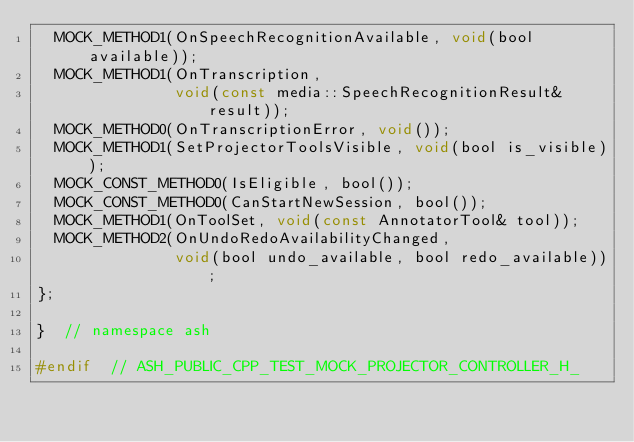Convert code to text. <code><loc_0><loc_0><loc_500><loc_500><_C_>  MOCK_METHOD1(OnSpeechRecognitionAvailable, void(bool available));
  MOCK_METHOD1(OnTranscription,
               void(const media::SpeechRecognitionResult& result));
  MOCK_METHOD0(OnTranscriptionError, void());
  MOCK_METHOD1(SetProjectorToolsVisible, void(bool is_visible));
  MOCK_CONST_METHOD0(IsEligible, bool());
  MOCK_CONST_METHOD0(CanStartNewSession, bool());
  MOCK_METHOD1(OnToolSet, void(const AnnotatorTool& tool));
  MOCK_METHOD2(OnUndoRedoAvailabilityChanged,
               void(bool undo_available, bool redo_available));
};

}  // namespace ash

#endif  // ASH_PUBLIC_CPP_TEST_MOCK_PROJECTOR_CONTROLLER_H_
</code> 